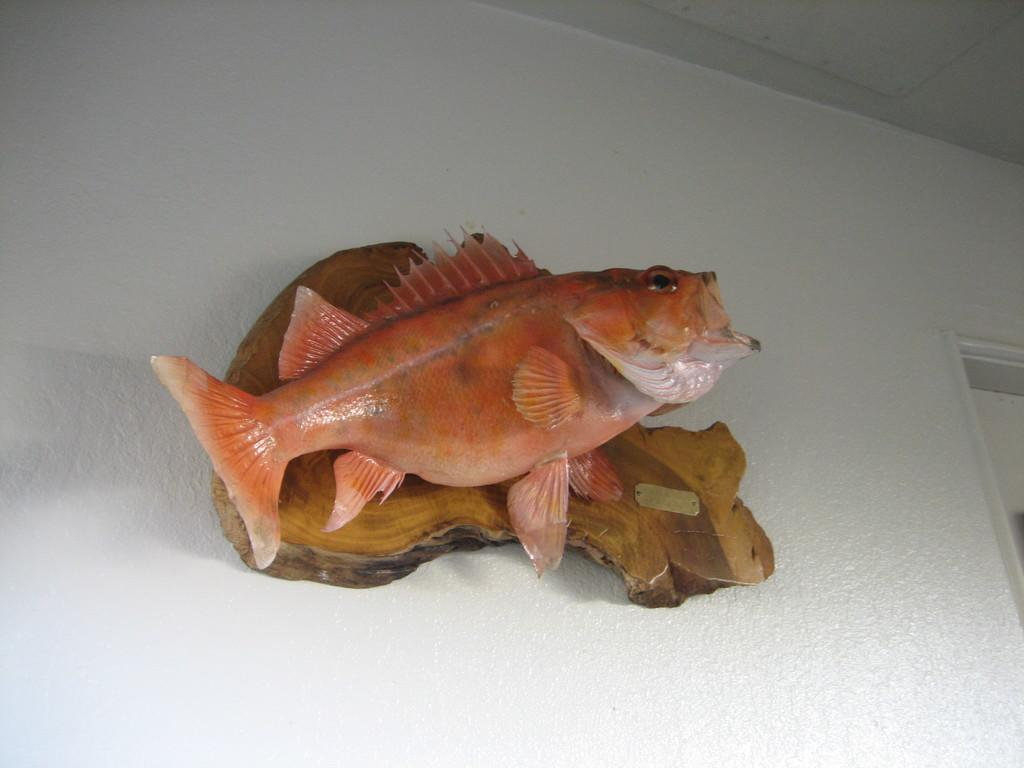What is the main subject of the image? There is a depiction of a fish in the center of the image. Where is the fish located in the image? The fish is attached to a plain wall. What part of the room can be seen above the fish? The ceiling is visible in the image. What type of curtain is hanging in front of the fish in the image? There is no curtain present in the image; the fish is attached to a plain wall. How does the fish express its anger in the image? The fish does not express anger in the image, as it is a static depiction on a wall. 